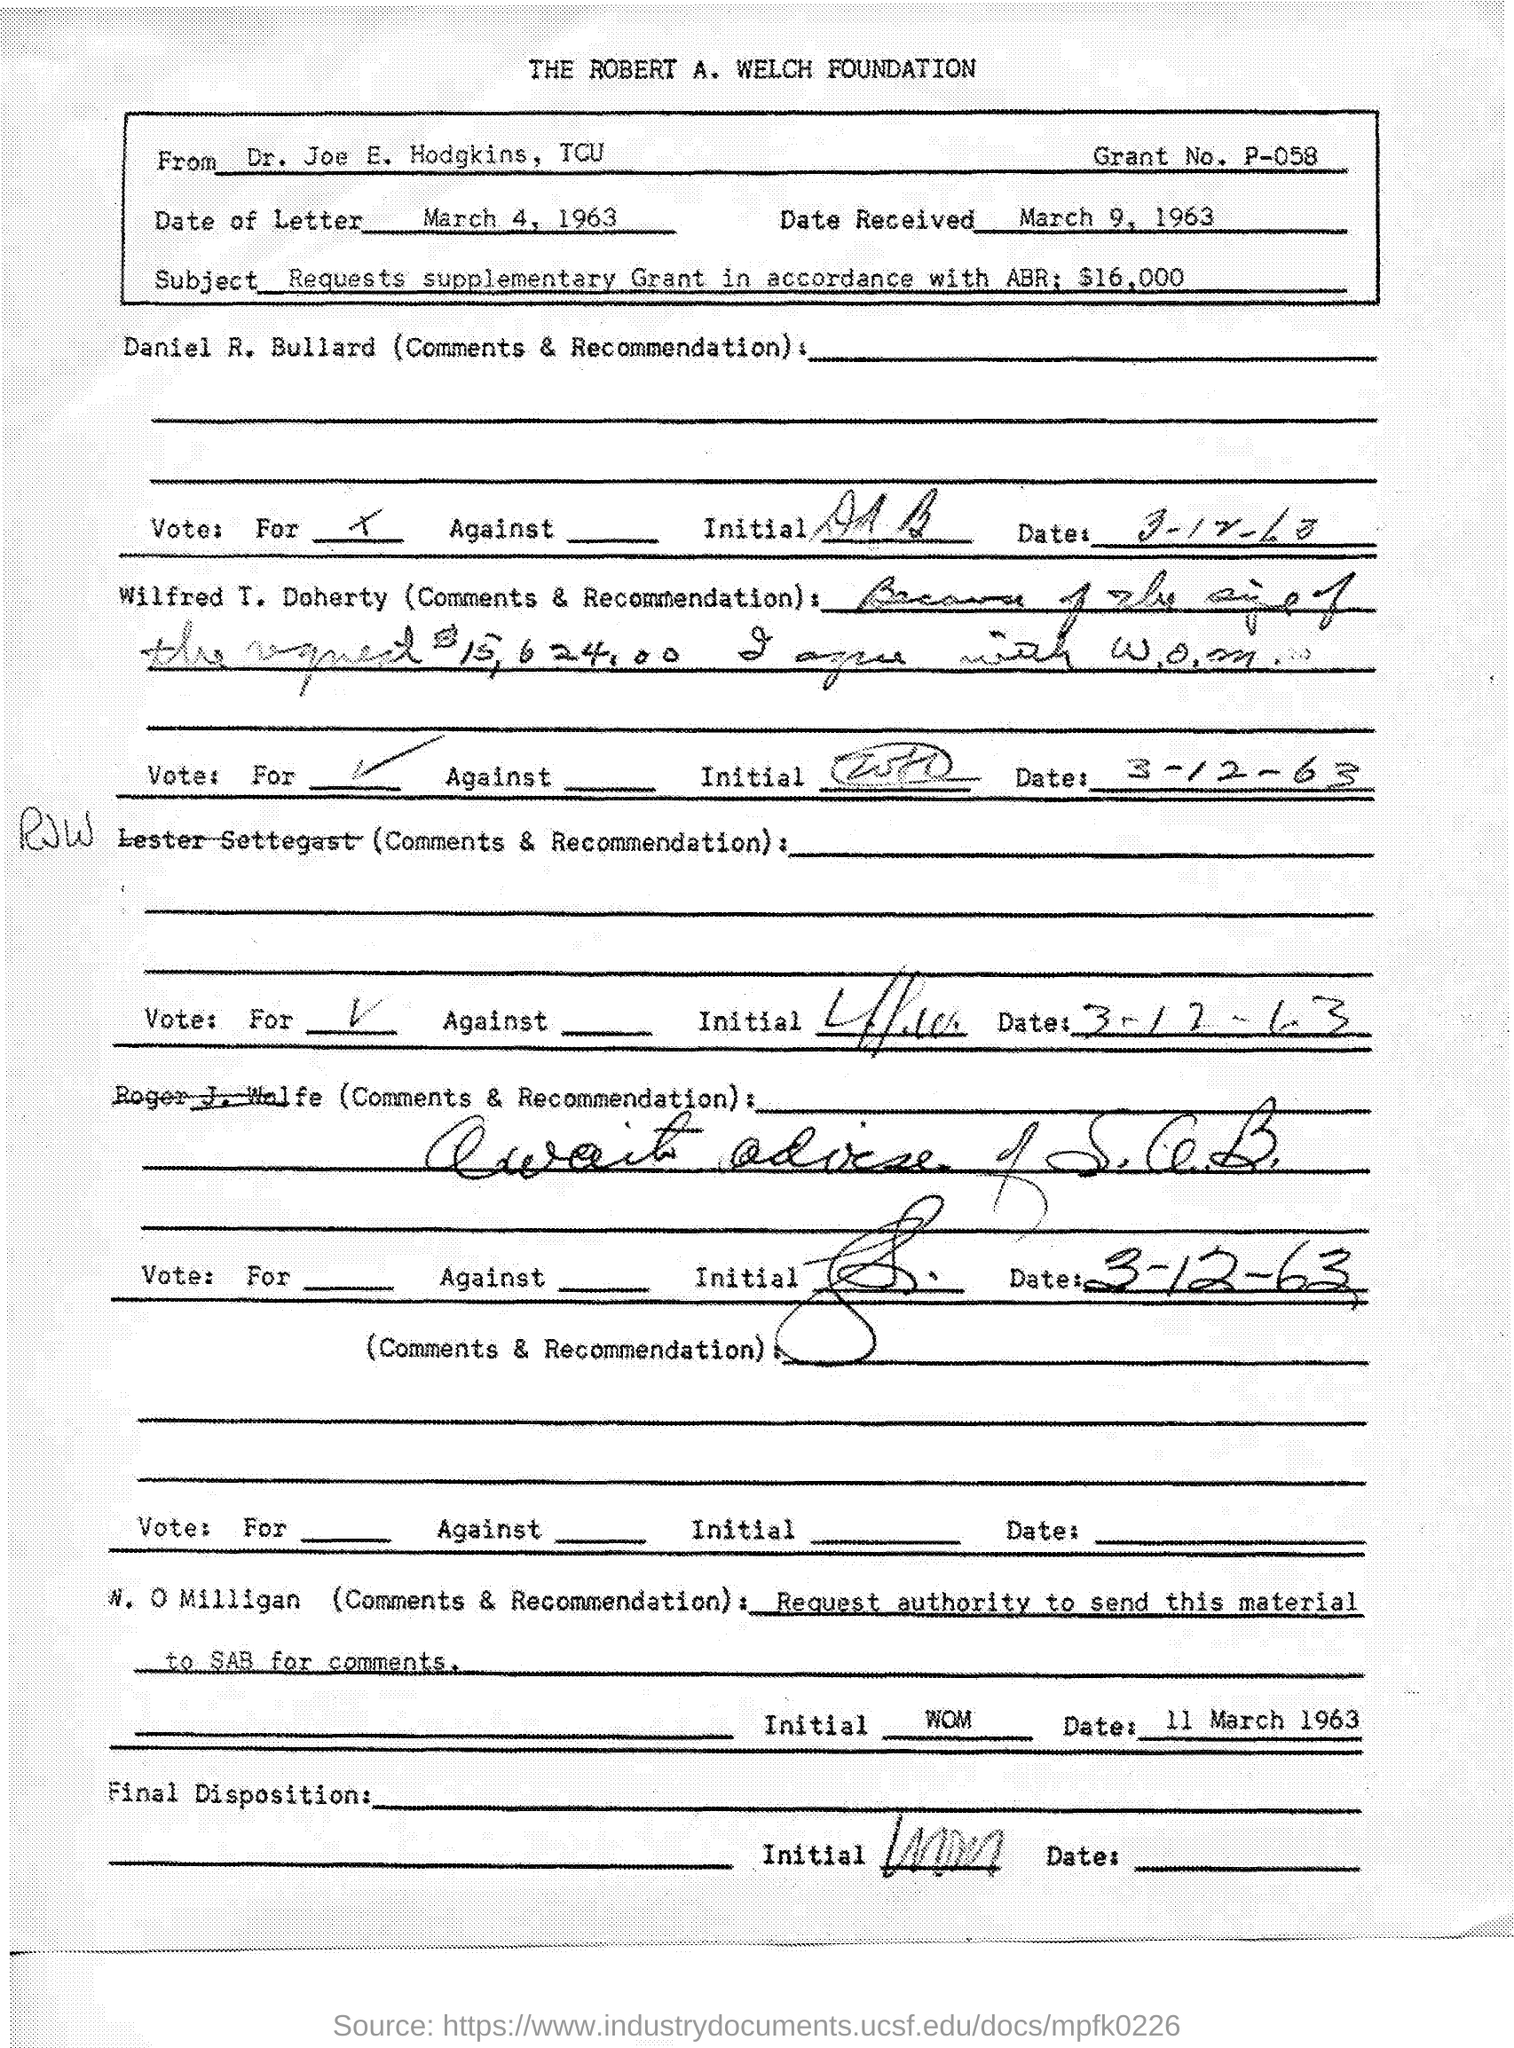Give some essential details in this illustration. The subject of the letter is requesting a supplementary grant in accordance with the ABR, for a total of $16,000. The letter was received on March 9, 1963. The Robert A. Welch Foundation is mentioned at the top of the page. The grant number is P-058.. The document is from Dr. Joe E. Hodgkins of TCU. 